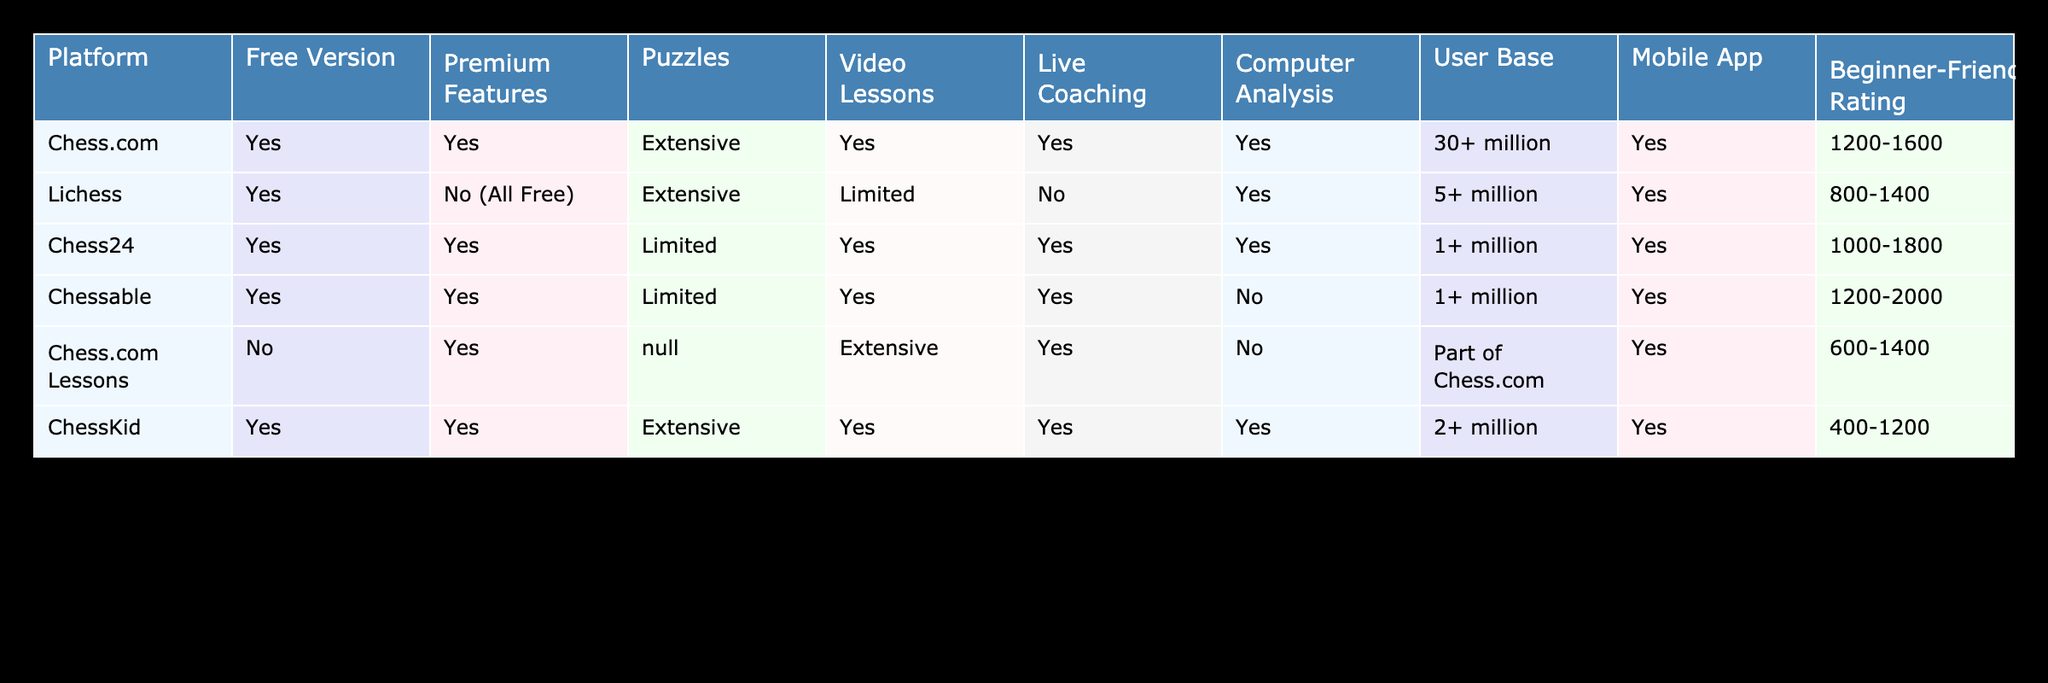What chess platforms offer a free version? The table lists several platforms and their free version status. We can see that Chess.com, Lichess, Chess24, Chessable, Chess.com Lessons, and ChessKid all offer a free version.
Answer: Chess.com, Lichess, Chess24, Chessable, Chess.com Lessons, ChessKid Which platform has the largest user base? By looking at the user base column, Chess.com has over 30 million users, while Lichess has 5 million users and the others have 1 or 2 million. Thus, Chess.com has the largest user base.
Answer: Chess.com Does Lichess offer any premium features? The table indicates that Lichess does not have premium features, as it states "No (All Free)" under the Premium Features column.
Answer: No Which platforms provide live coaching? Reviewing the table, we find that Chess.com, Chess24, Chessable, and ChessKid provide live coaching, while Lichess does not.
Answer: Chess.com, Chess24, Chessable, ChessKid What is the average beginner-friendly rating for platforms that offer extensive puzzles? The platforms offering extensive puzzles are Chess.com, Lichess, Chess24, and ChessKid, with their beginner-friendly ratings being 1200-1600, 800-1400, 1000-1800, and 400-1200, respectively. To compute the average, we convert these ranges to their respective midpoints: 1400, 1200, 1300, and 800. So, the average is (1400 + 1200 + 1300 + 800) / 4 = 1275.
Answer: 1275 Which chess platform has the best beginner-friendly rating and offers video lessons? Analyzing the ratings alongside whether they offer video lessons shows Chessable yields a beginner-friendly rating of 1200-2000 with video lessons available. Meanwhile, Chess.com also provides video lessons but with a rating of 1200-1600. Since Chessable has the higher rating range, it has the best rating.
Answer: Chessable Are there any platforms that offer computer analysis but not live coaching? From the table, Chessable is the only platform that provides computer analysis but does not offer live coaching.
Answer: Yes, Chessable What percentage of platforms mentioned offer a mobile app? According to the table, there are 6 platforms in total. All of them (6 out of 6) have a mobile app, leading to 100% of the platforms offering this feature.
Answer: 100% 